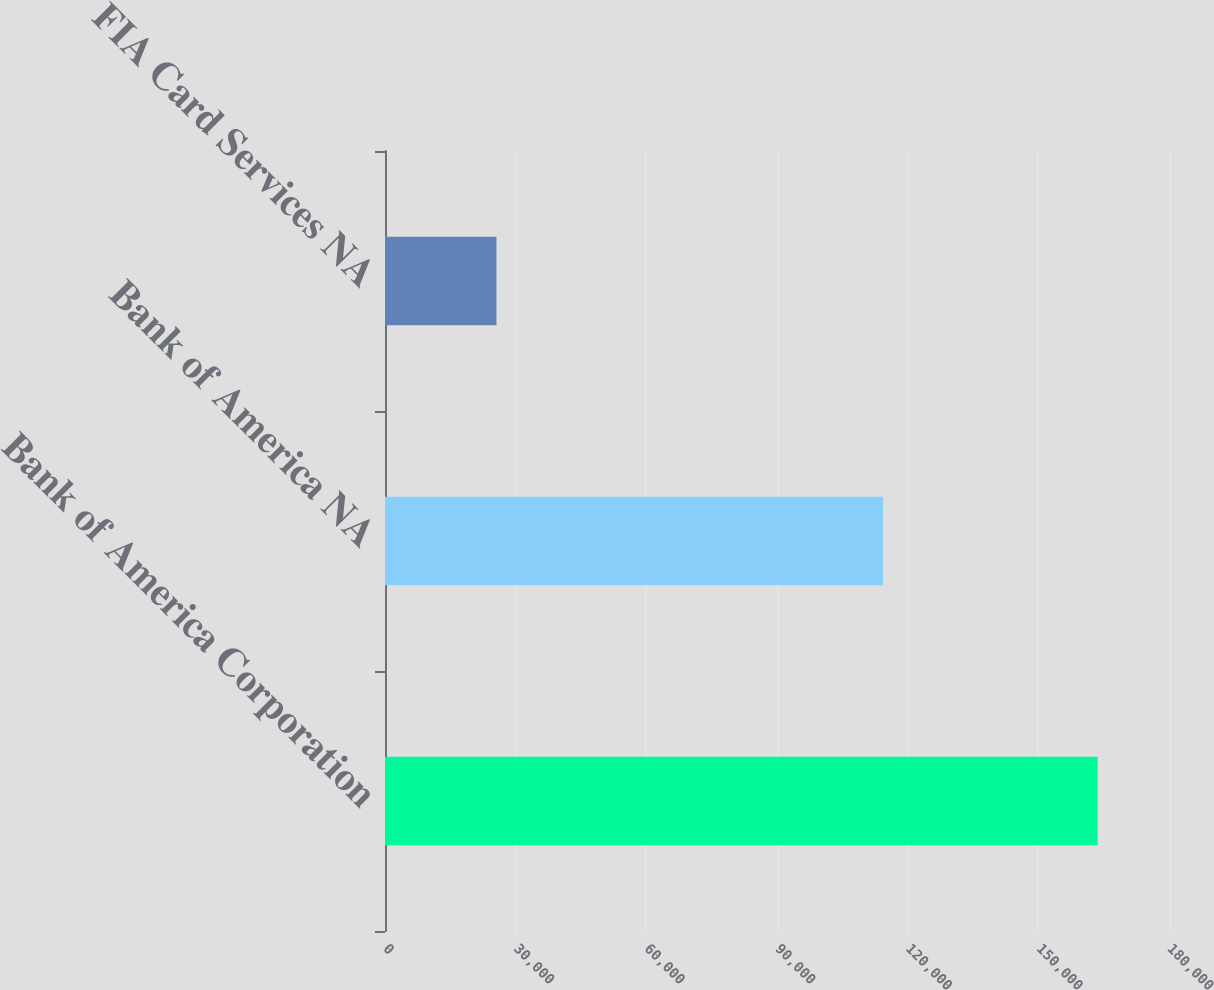Convert chart to OTSL. <chart><loc_0><loc_0><loc_500><loc_500><bar_chart><fcel>Bank of America Corporation<fcel>Bank of America NA<fcel>FIA Card Services NA<nl><fcel>163626<fcel>114345<fcel>25589<nl></chart> 